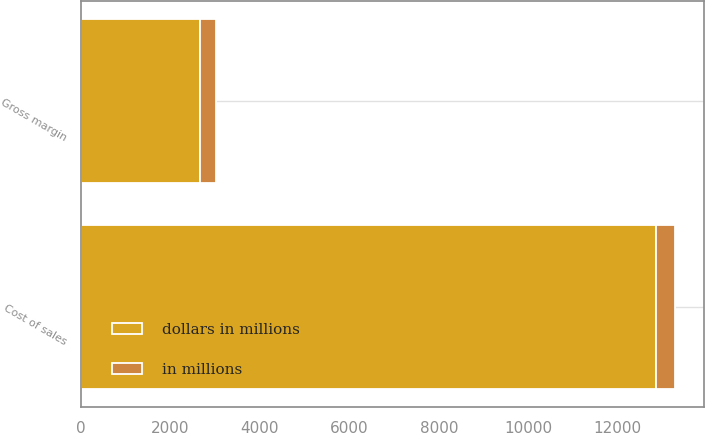Convert chart. <chart><loc_0><loc_0><loc_500><loc_500><stacked_bar_chart><ecel><fcel>Cost of sales<fcel>Gross margin<nl><fcel>dollars in millions<fcel>12861<fcel>2658<nl><fcel>in millions<fcel>414<fcel>352<nl></chart> 